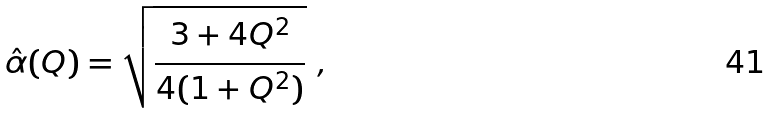Convert formula to latex. <formula><loc_0><loc_0><loc_500><loc_500>\hat { \alpha } ( Q ) = \sqrt { { \frac { 3 + 4 Q ^ { 2 } } { 4 ( 1 + Q ^ { 2 } ) } } } \ ,</formula> 